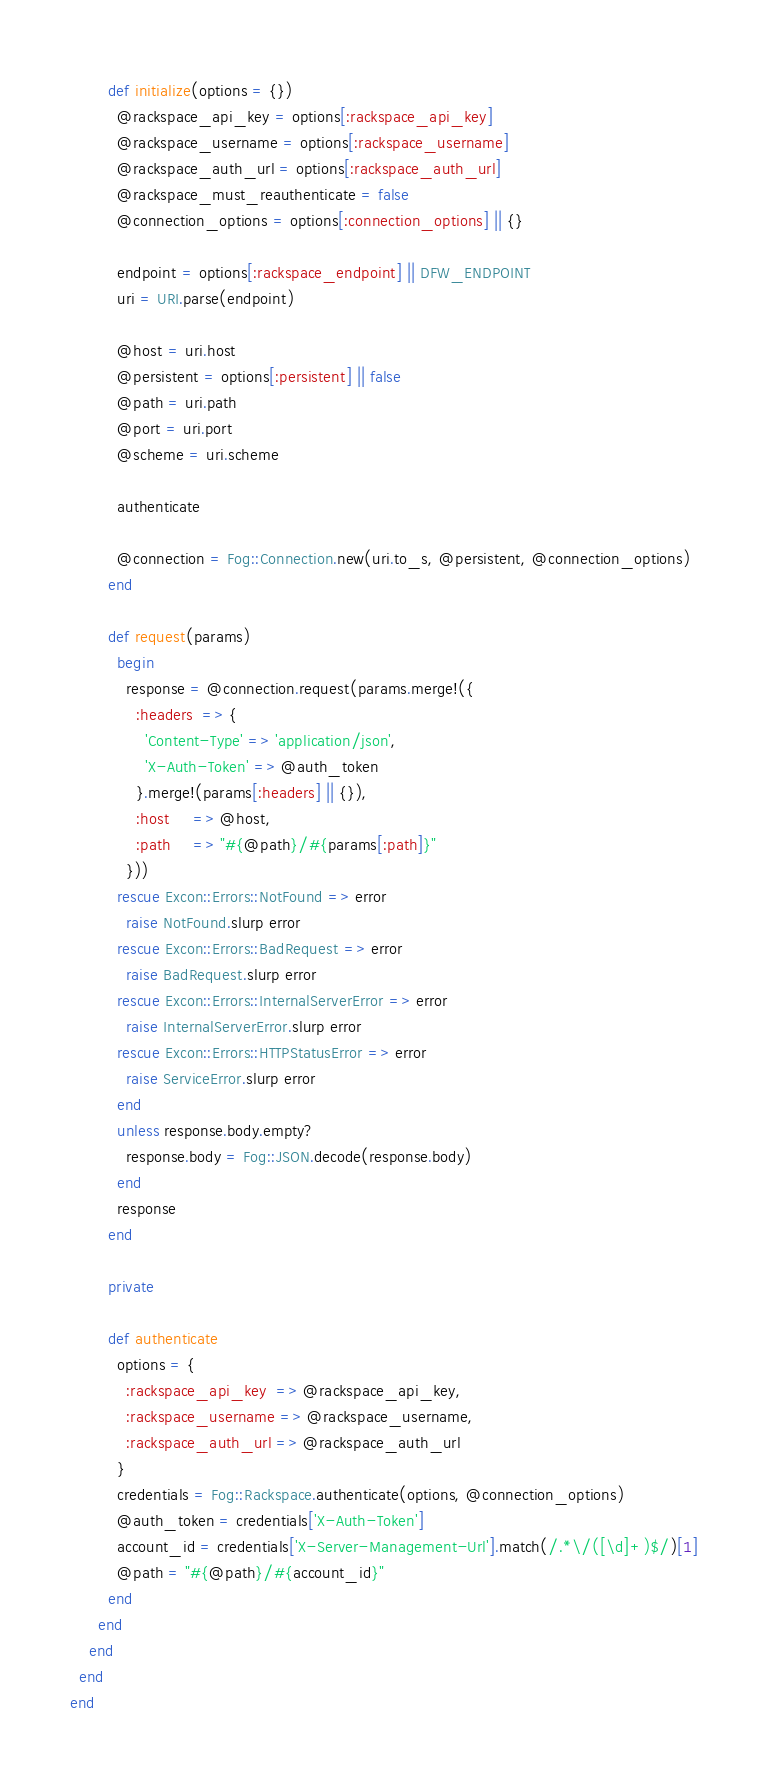<code> <loc_0><loc_0><loc_500><loc_500><_Ruby_>        def initialize(options = {})
          @rackspace_api_key = options[:rackspace_api_key]
          @rackspace_username = options[:rackspace_username]
          @rackspace_auth_url = options[:rackspace_auth_url]
          @rackspace_must_reauthenticate = false
          @connection_options = options[:connection_options] || {}

          endpoint = options[:rackspace_endpoint] || DFW_ENDPOINT
          uri = URI.parse(endpoint)

          @host = uri.host
          @persistent = options[:persistent] || false
          @path = uri.path
          @port = uri.port
          @scheme = uri.scheme

          authenticate

          @connection = Fog::Connection.new(uri.to_s, @persistent, @connection_options)
        end

        def request(params)
          begin
            response = @connection.request(params.merge!({
              :headers  => {
                'Content-Type' => 'application/json',
                'X-Auth-Token' => @auth_token
              }.merge!(params[:headers] || {}),
              :host     => @host,
              :path     => "#{@path}/#{params[:path]}"
            }))
          rescue Excon::Errors::NotFound => error
            raise NotFound.slurp error
          rescue Excon::Errors::BadRequest => error
            raise BadRequest.slurp error
          rescue Excon::Errors::InternalServerError => error
            raise InternalServerError.slurp error
          rescue Excon::Errors::HTTPStatusError => error
            raise ServiceError.slurp error
          end
          unless response.body.empty?
            response.body = Fog::JSON.decode(response.body)
          end
          response
        end

        private

        def authenticate
          options = {
            :rackspace_api_key  => @rackspace_api_key,
            :rackspace_username => @rackspace_username,
            :rackspace_auth_url => @rackspace_auth_url
          }
          credentials = Fog::Rackspace.authenticate(options, @connection_options)
          @auth_token = credentials['X-Auth-Token']
          account_id = credentials['X-Server-Management-Url'].match(/.*\/([\d]+)$/)[1]
          @path = "#{@path}/#{account_id}"
        end
      end
    end
  end
end
</code> 